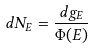<formula> <loc_0><loc_0><loc_500><loc_500>d N _ { E } = \frac { d g _ { E } } { \Phi ( E ) }</formula> 